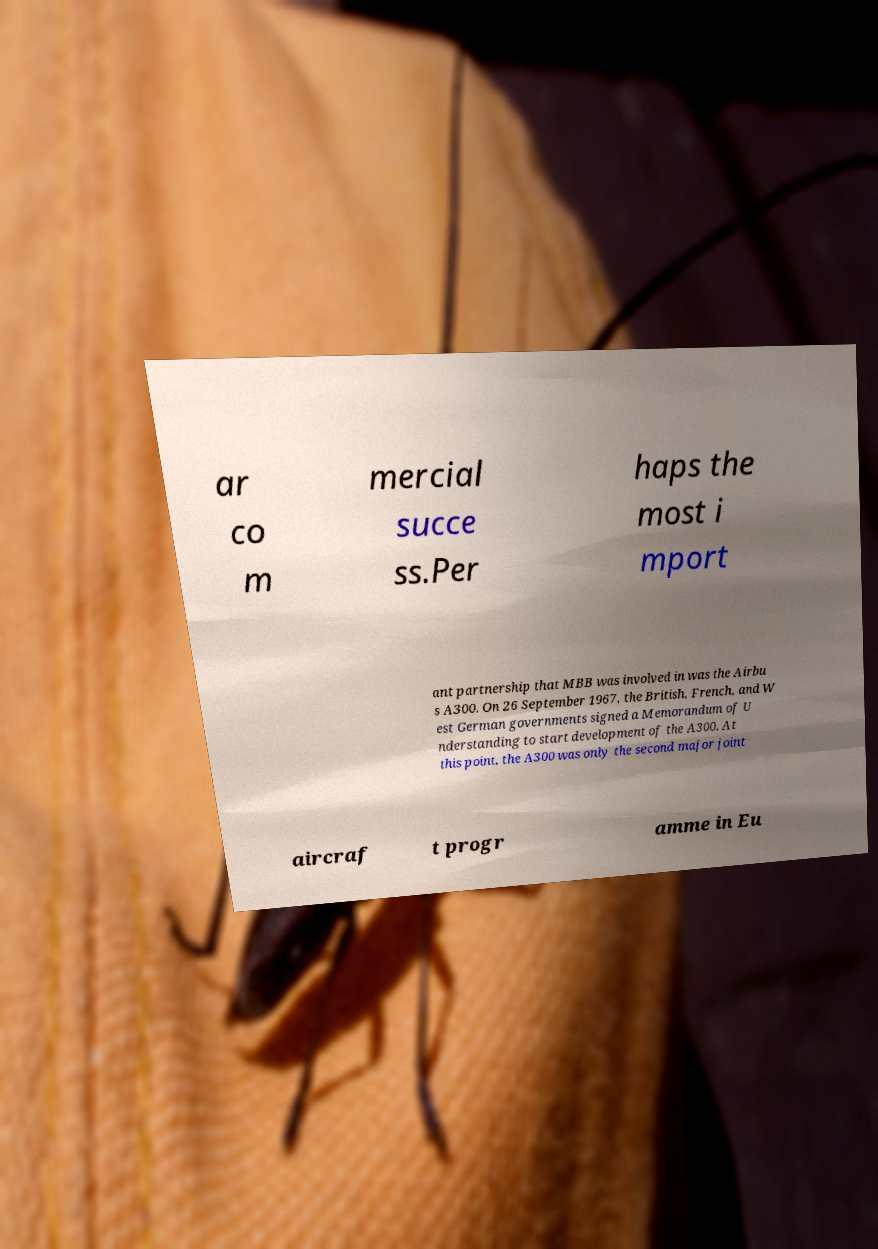What messages or text are displayed in this image? I need them in a readable, typed format. ar co m mercial succe ss.Per haps the most i mport ant partnership that MBB was involved in was the Airbu s A300. On 26 September 1967, the British, French, and W est German governments signed a Memorandum of U nderstanding to start development of the A300. At this point, the A300 was only the second major joint aircraf t progr amme in Eu 